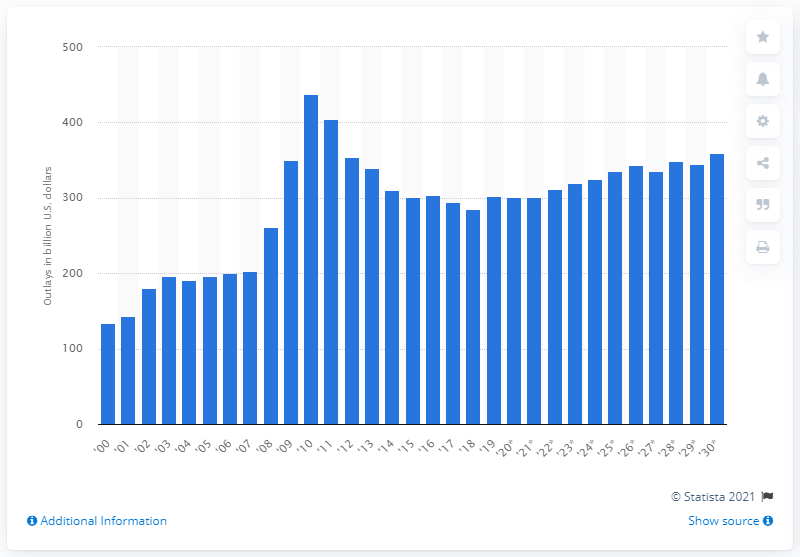Mention a couple of crucial points in this snapshot. The projected increase in income security outlays for 2030 is expected to be [insert value]. In 2019, the amount of income security outlays was 301. 